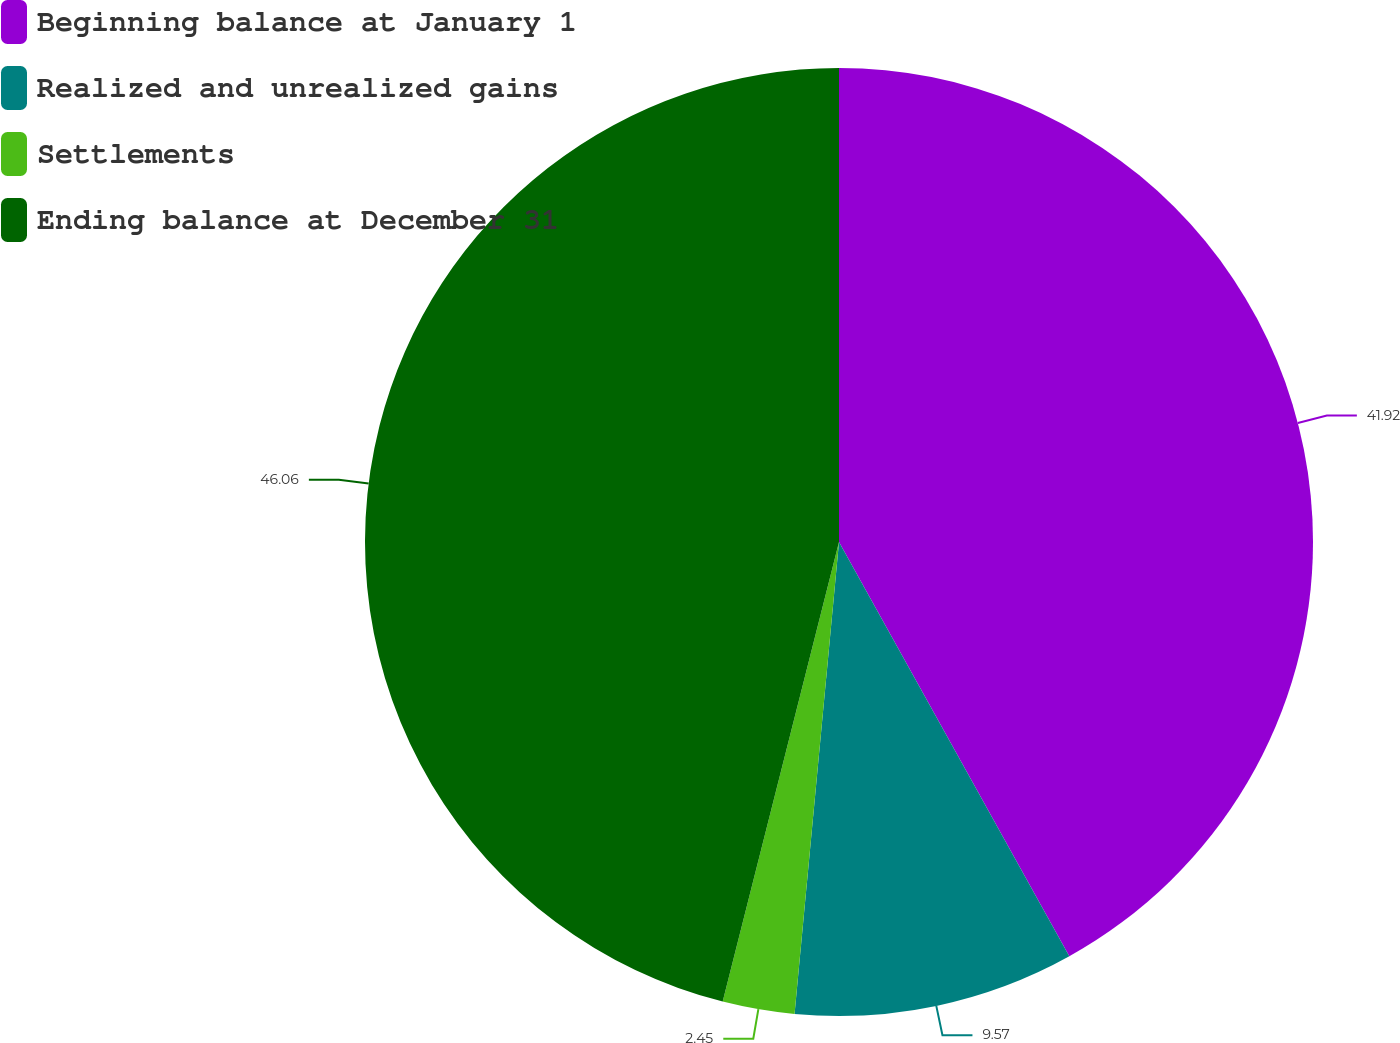Convert chart to OTSL. <chart><loc_0><loc_0><loc_500><loc_500><pie_chart><fcel>Beginning balance at January 1<fcel>Realized and unrealized gains<fcel>Settlements<fcel>Ending balance at December 31<nl><fcel>41.92%<fcel>9.57%<fcel>2.45%<fcel>46.05%<nl></chart> 